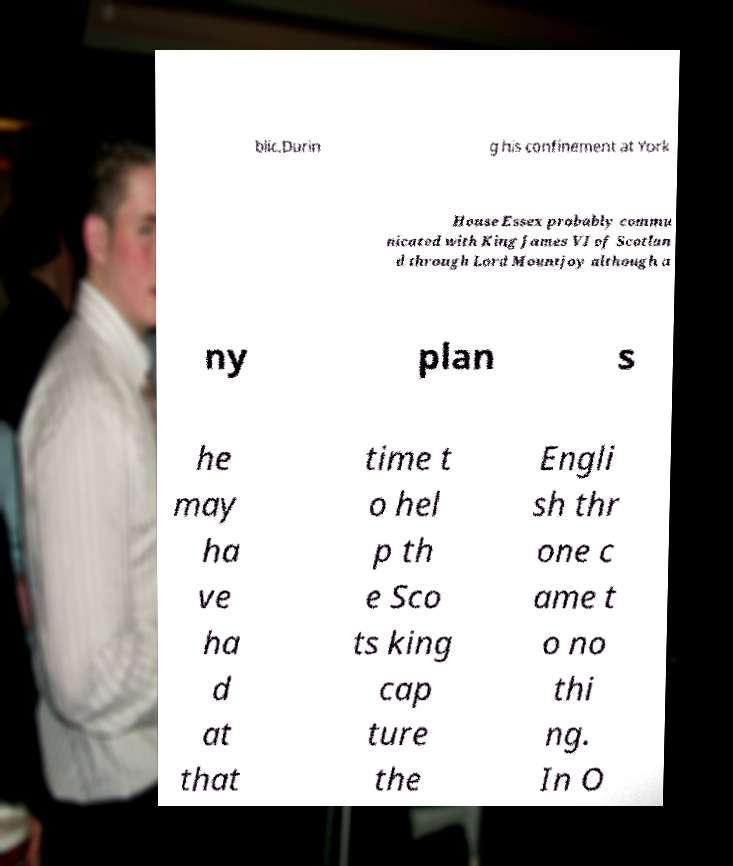Could you extract and type out the text from this image? blic.Durin g his confinement at York House Essex probably commu nicated with King James VI of Scotlan d through Lord Mountjoy although a ny plan s he may ha ve ha d at that time t o hel p th e Sco ts king cap ture the Engli sh thr one c ame t o no thi ng. In O 